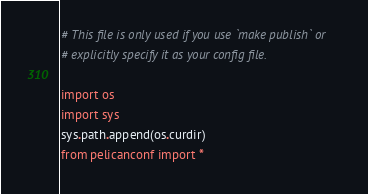<code> <loc_0><loc_0><loc_500><loc_500><_Python_># This file is only used if you use `make publish` or
# explicitly specify it as your config file.

import os
import sys
sys.path.append(os.curdir)
from pelicanconf import *
</code> 